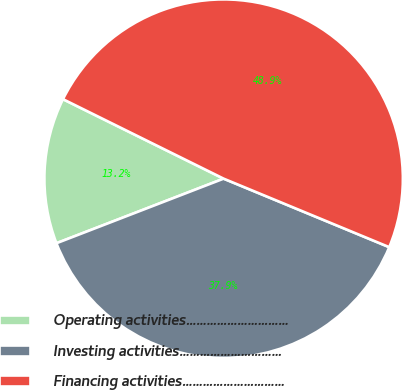<chart> <loc_0><loc_0><loc_500><loc_500><pie_chart><fcel>Operating activities…………………………<fcel>Investing activities…………………………<fcel>Financing activities…………………………<nl><fcel>13.18%<fcel>37.89%<fcel>48.93%<nl></chart> 